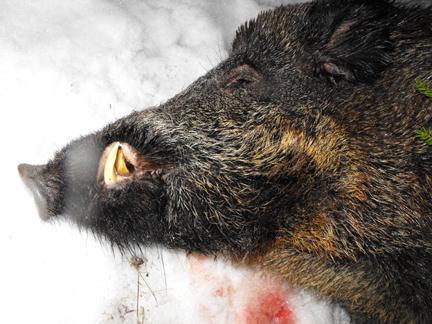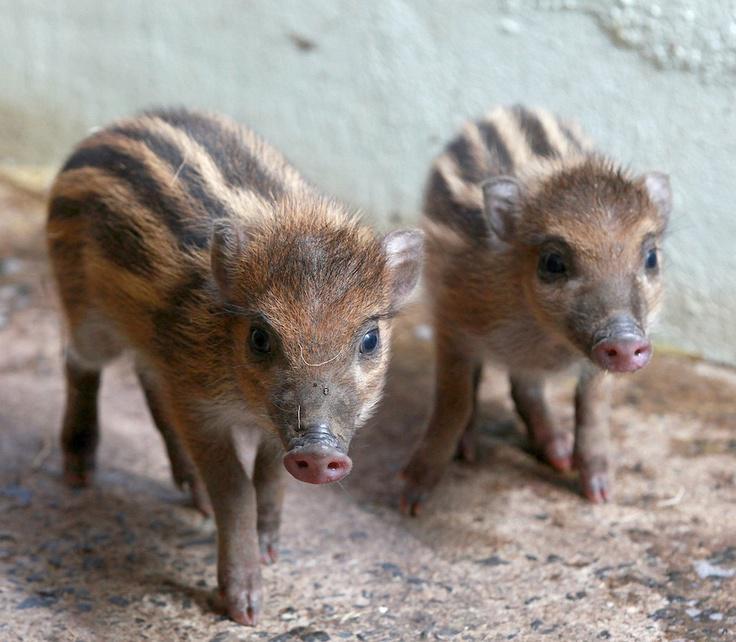The first image is the image on the left, the second image is the image on the right. Evaluate the accuracy of this statement regarding the images: "An image contains at least two baby piglets with distinctive brown and beige striped fur, who are standing on all fours and facing forward.". Is it true? Answer yes or no. Yes. The first image is the image on the left, the second image is the image on the right. Assess this claim about the two images: "There are exactly four pigs.". Correct or not? Answer yes or no. No. 